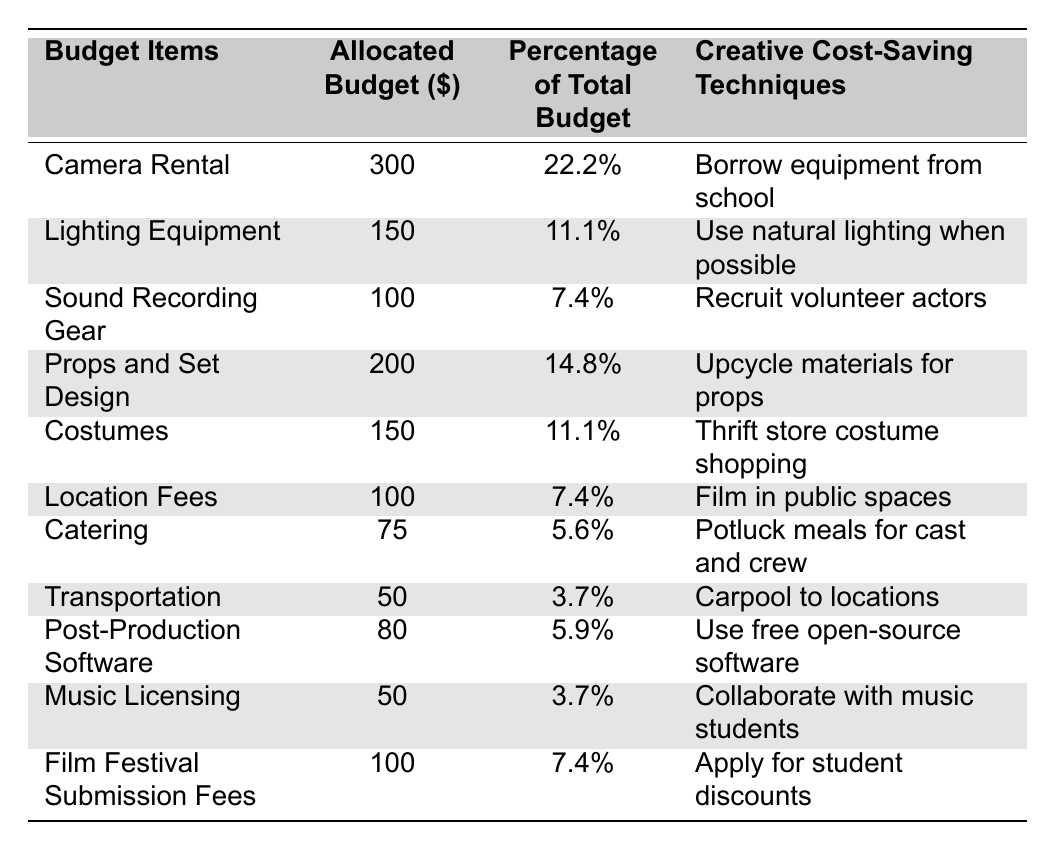What is the allocated budget for Camera Rental? The table lists the allocated budget for Camera Rental in the second column. That value is 300.
Answer: 300 Which budget item has the lowest allocated budget? By comparing the values in the allocated budget column, the lowest amount is 50, which corresponds to both Transportation and Music Licensing.
Answer: 50 What is the total allocated budget for all items? To find the total allocated budget, we add up all the values in the allocated budget column: 300 + 150 + 100 + 200 + 150 + 100 + 75 + 50 + 80 + 50 + 100 = 1,455.
Answer: 1,455 What percentage of the total budget is spent on Catering? The table indicates that the allocated budget for Catering is 75, and its percentage of the total budget can be found in the third column, which shows 5.6%.
Answer: 5.6% Is the allocated budget for Props and Set Design greater than the combined total for Transportation and Music Licensing? The allocated budget for Props and Set Design is 200, while the combined total for Transportation (50) and Music Licensing (50) is 100. Since 200 is greater than 100, the answer is yes.
Answer: Yes What is the average allocated budget for all listed items? To find the average, we first calculate the total allocated budget, which is 1,455, then divide that by the number of items listed (11): 1,455 / 11 ≈ 132.27.
Answer: 132.27 How much more is allocated to Camera Rental compared to Location Fees? The allocated budget for Camera Rental is 300, while for Location Fees, it is 100. The difference is 300 - 100 = 200.
Answer: 200 Which budget item has the highest percentage of total budget? The item with the highest percentage is Camera Rental, as it has 22.2%, the value found in the third column.
Answer: Camera Rental Are the creative cost-saving techniques for Sound Recording Gear and Costumes identical? The techniques listed are "Recruit volunteer actors" for Sound Recording Gear and "Thrift store costume shopping" for Costumes. Since the techniques differ, the answer is no.
Answer: No What is the total allocated budget for items that have a 7.4% percentage of the total budget? The items with a 7.4% percentage are Sound Recording Gear, Location Fees, and Film Festival Submission Fees. Their allocated budgets add up to: 100 + 100 + 100 = 300.
Answer: 300 What cost-saving technique is associated with using the lowest percentage of total budget? The lowest percentage of total budget is 3.7%, which is associated with Transportation and Music Licensing. The techniques are "Carpool to locations" for Transportation and "Collaborate with music students" for Music Licensing. Therefore, the answer contains both techniques: carpooling and collaboration.
Answer: Carpool to locations, Collaborate with music students 